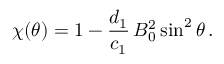<formula> <loc_0><loc_0><loc_500><loc_500>\chi ( \theta ) = 1 - \frac { d _ { 1 } } { c _ { 1 } } \, B _ { 0 } ^ { 2 } \sin ^ { 2 } \theta \, .</formula> 